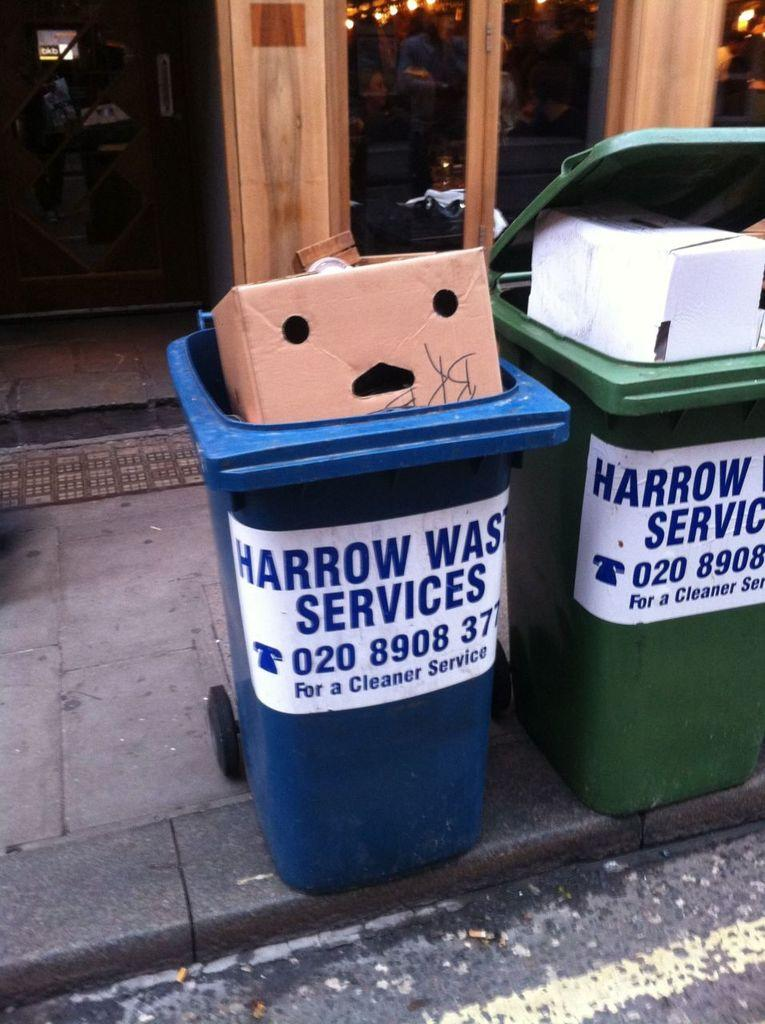<image>
Give a short and clear explanation of the subsequent image. Harrow Waste Services has bins for trash and recycling at the curb. 